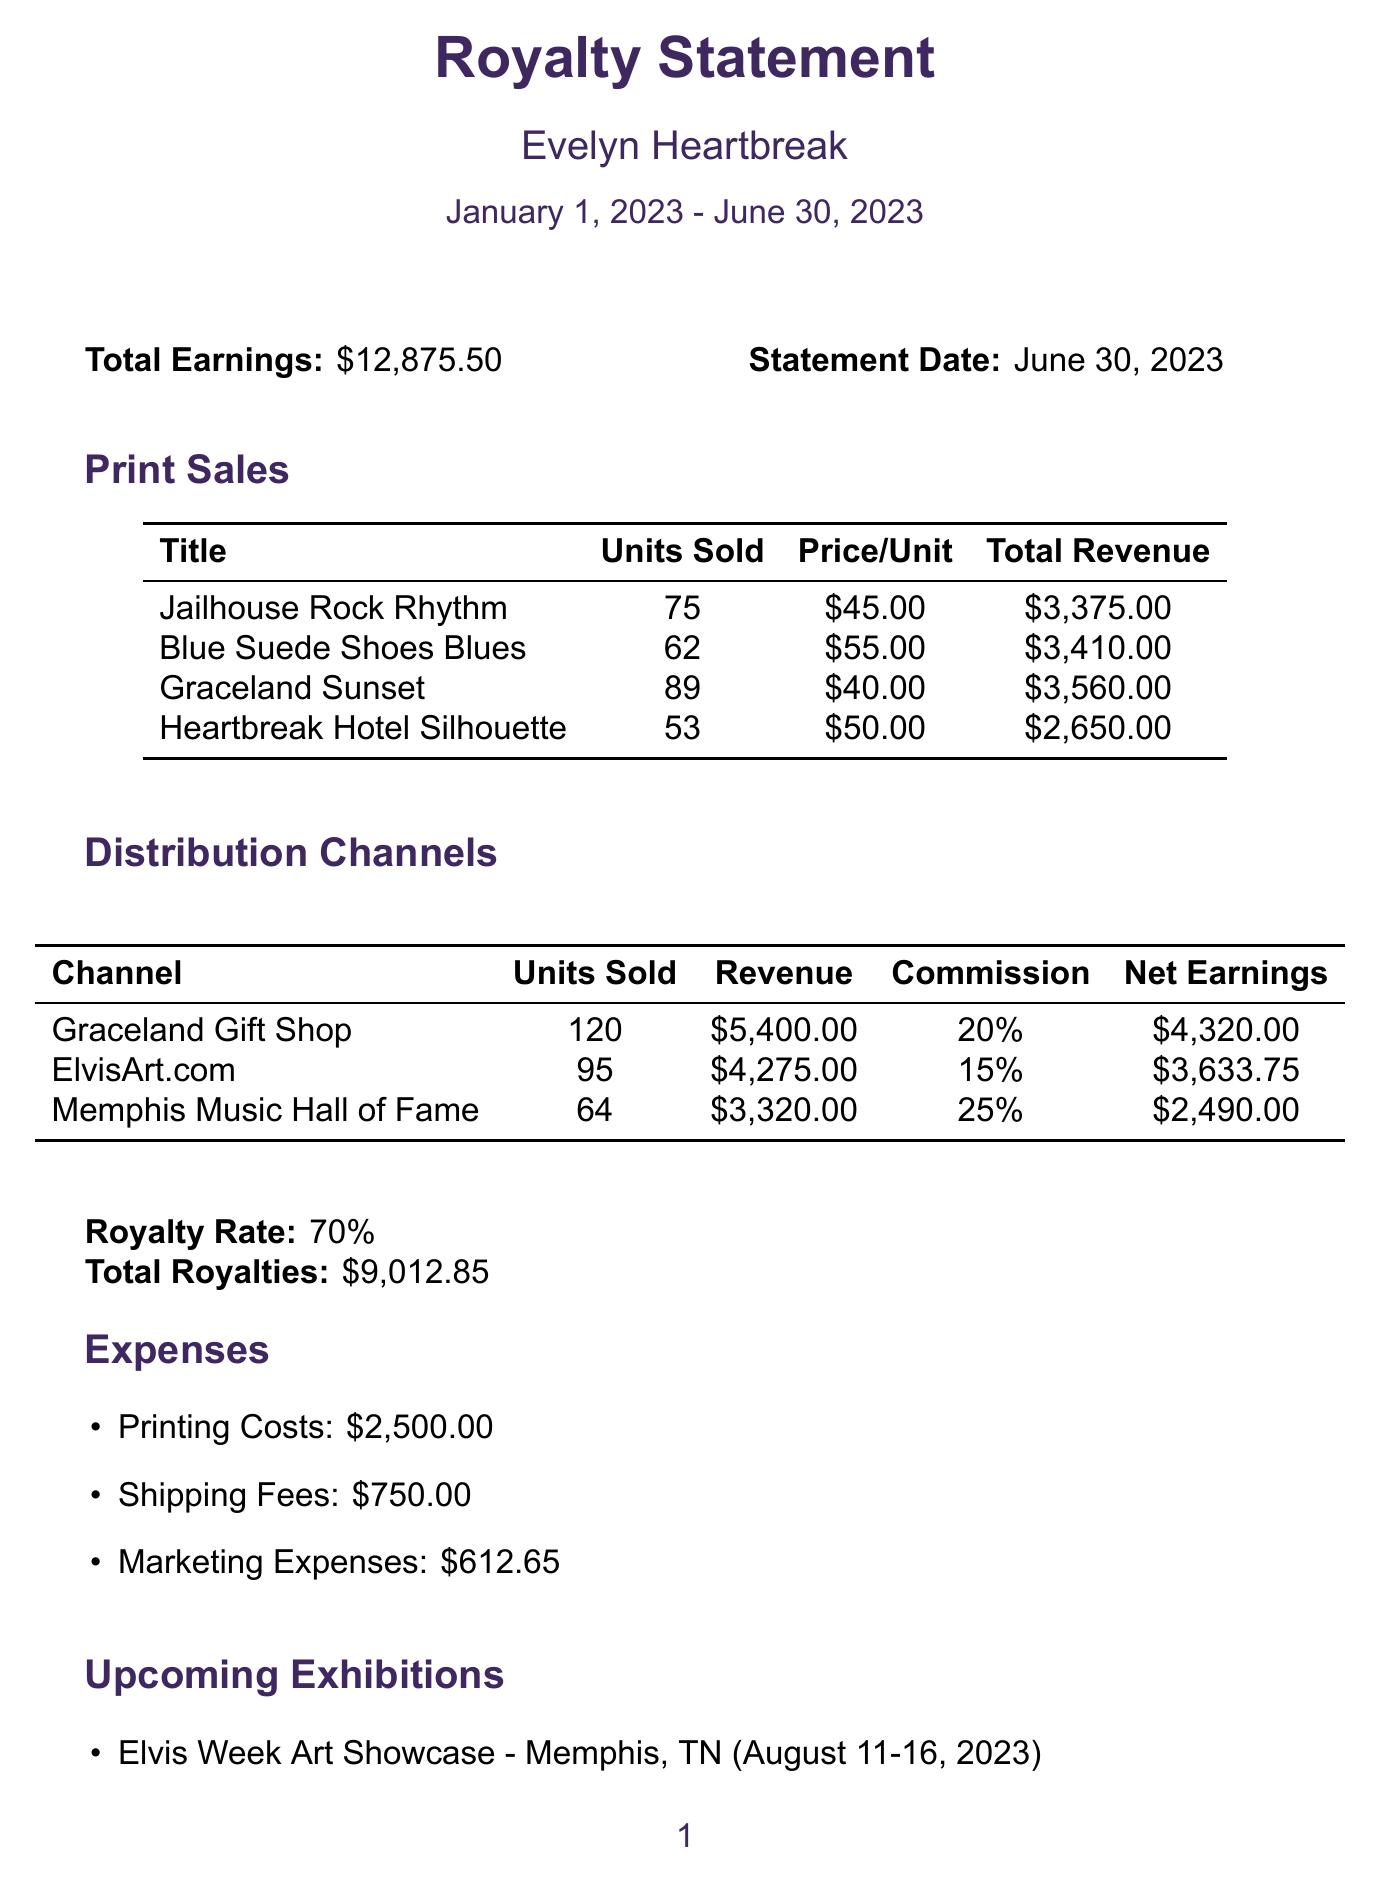What is the total earnings? The total earnings are explicitly mentioned in the document as $12,875.50.
Answer: $12,875.50 Who is the artist? The artist's name is stated clearly at the top of the document.
Answer: Evelyn Heartbreak What is the royalty rate? The royalty rate is specified in the document.
Answer: 70% How many units were sold for "Graceland Sunset"? The number of units sold for "Graceland Sunset" is provided in the print sales section.
Answer: 89 Which distribution channel had the highest revenue? By comparing the revenue figures in the distribution channels section, Graceland Gift Shop has the highest.
Answer: Graceland Gift Shop What are the printing costs? The printing costs are listed in the expenses section of the document.
Answer: $2,500.00 When is the Elvis Week Art Showcase? The date for the Elvis Week Art Showcase is mentioned in the upcoming exhibitions section.
Answer: August 11-16, 2023 How many pre-orders does "Viva Las Vegas Lights" have? The number of pre-orders for "Viva Las Vegas Lights" is detailed in the new print releases section.
Answer: 35 What is the total revenue from "Heartbreak Hotel Silhouette"? The total revenue from "Heartbreak Hotel Silhouette" is included in the print sales information.
Answer: $2,650.00 